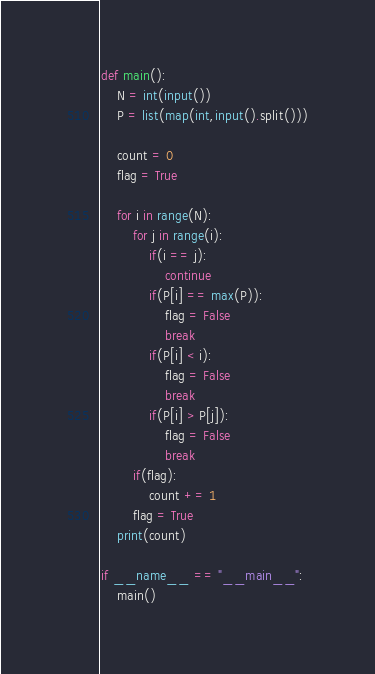<code> <loc_0><loc_0><loc_500><loc_500><_Python_>def main():
    N = int(input())
    P = list(map(int,input().split()))

    count = 0
    flag = True

    for i in range(N):
        for j in range(i):
            if(i == j):
                continue
            if(P[i] == max(P)):
                flag = False
                break
            if(P[i] < i):
                flag = False
                break
            if(P[i] > P[j]):
                flag = False
                break
        if(flag):
            count += 1
        flag = True
    print(count)

if __name__ == "__main__":
    main()
</code> 